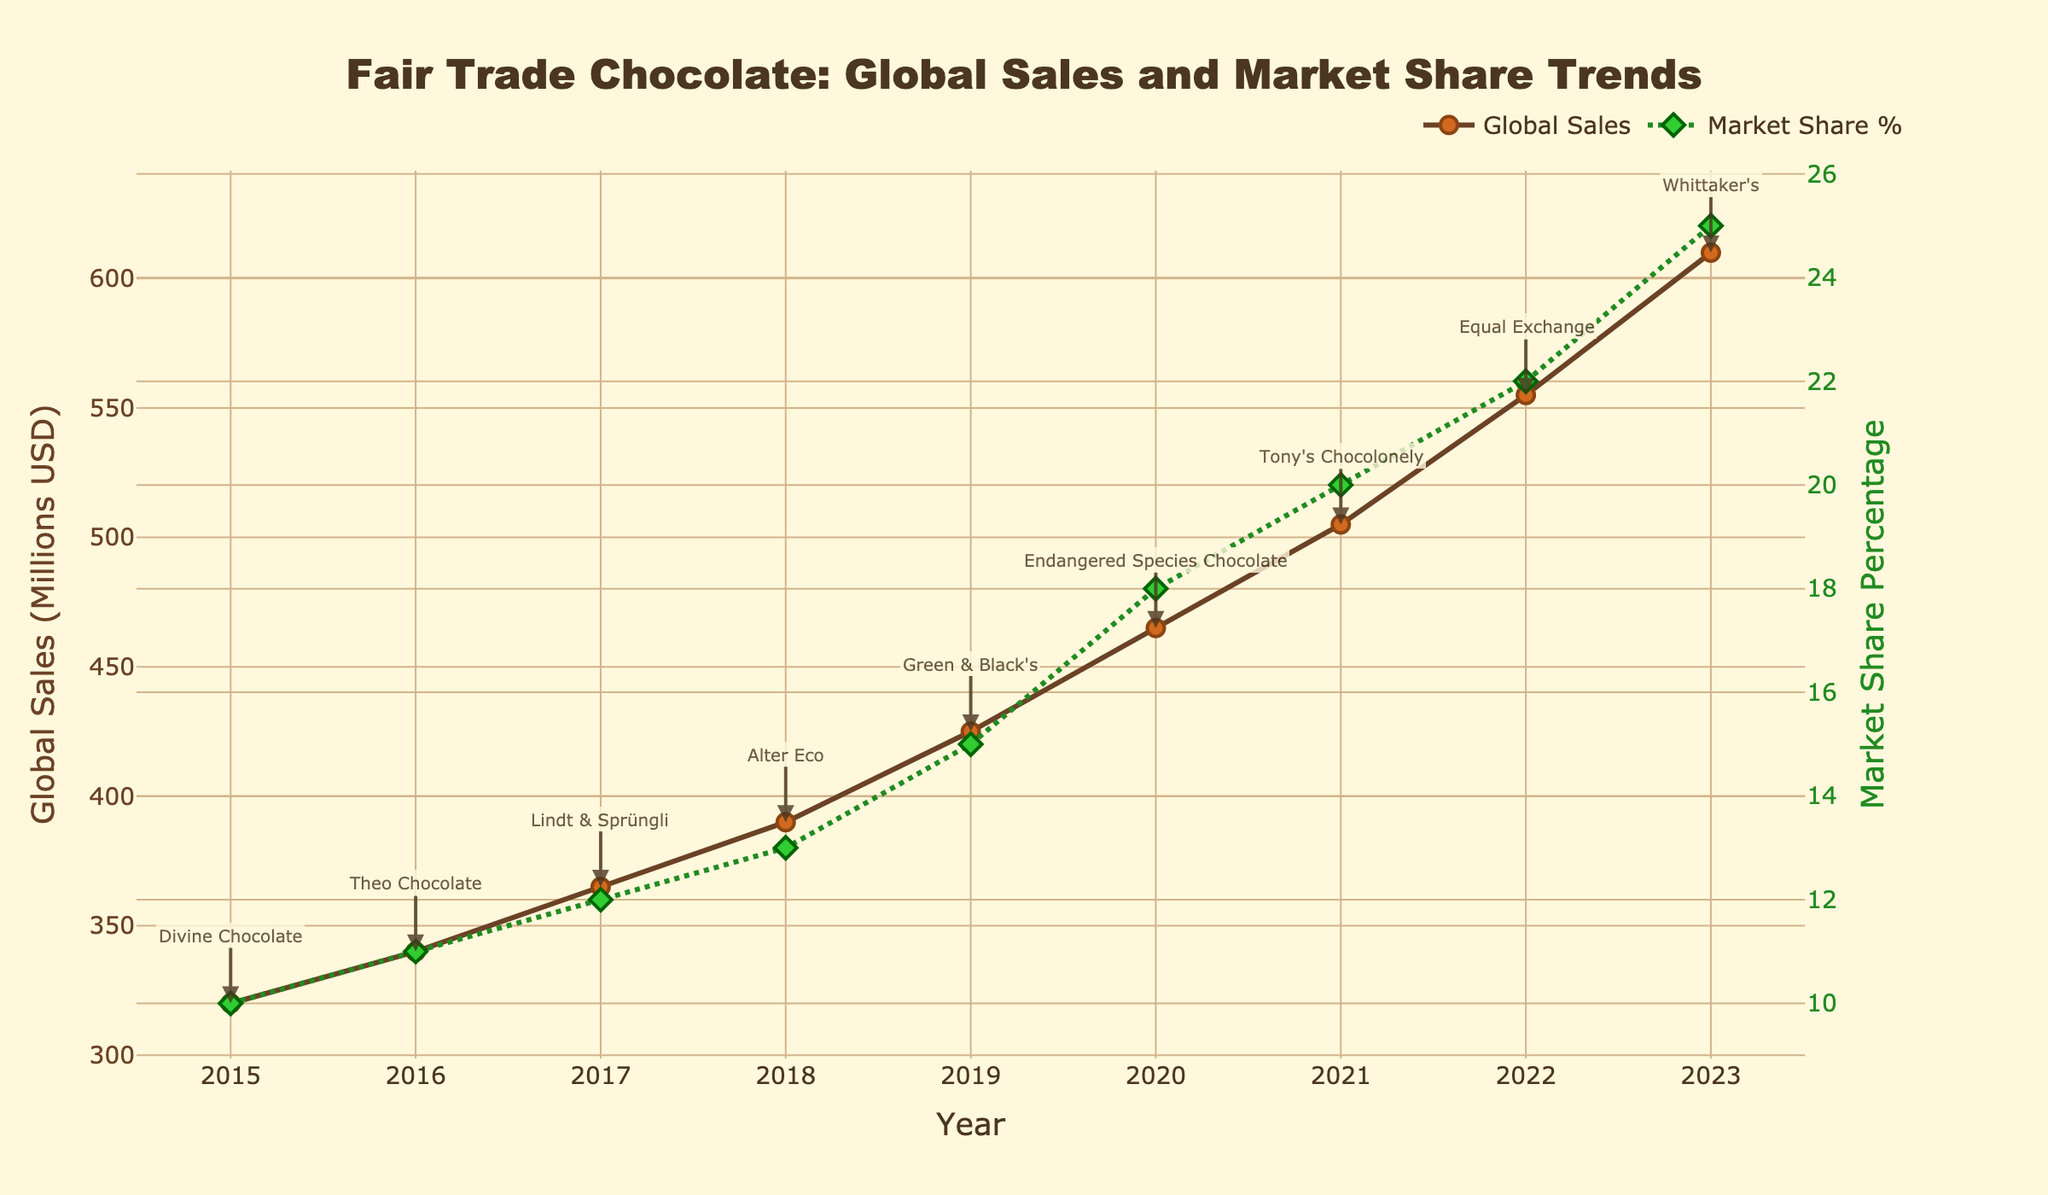What is the title of the graph? The title is typically at the top of the graph and provides a summary of what the graph is representing. Here, it reads "Fair Trade Chocolate: Global Sales and Market Share Trends"
Answer: Fair Trade Chocolate: Global Sales and Market Share Trends How many years are displayed on the x-axis? By visually counting the distinct points along the x-axis, you can see they represent yearly intervals from 2015 to 2023. This is a total of 9 years.
Answer: 9 What was the Global Sales value (in Millions USD) for Fair Trade Chocolate in 2020? Identify the year 2020 on the x-axis and refer to the Global Sales line to find the corresponding value. The label should show the sales as 465 million USD.
Answer: 465 Which year had the highest Market Share Percentage? By inspecting the secondary y-axis (right side) and checking the Market Share Percentage line, the peak point occurs in 2023 with a value of 25%.
Answer: 2023 How much did Global Sales of Fair Trade Chocolate increase from 2015 to 2023 (in Millions USD)? Subtract the Global Sales value in 2015 from that in 2023: 610 - 320 = 290 million USD.
Answer: 290 Which brand is associated with the year 2021? Check the annotation closest to the year 2021, where the brand Tony's Chocolonely is mentioned.
Answer: Tony's Chocolonely What is the trend in Global Sales between 2017 and 2020? Observe the Global Sales line between the years 2017 and 2020, noting the consistent upward slope indicating an increase each year from 365 to 465 (Millions USD).
Answer: Increasing Compare the rate of increase in Market Share Percentage between 2015-2018 and 2019-2023. Which period had a higher rate of increase? Calculate the rate of increase for each period and compare. For 2015-2018: (13-10)/3 = 1% per year; for 2019-2023: (25-15)/4 = 2.5% per year. 2019-2023 had a higher rate.
Answer: 2019-2023 What was the Market Share Percentage change from 2021 to 2022? Subtract the Market Share Percentage in 2021 from that in 2022: 22 - 20 = 2%.
Answer: 2 